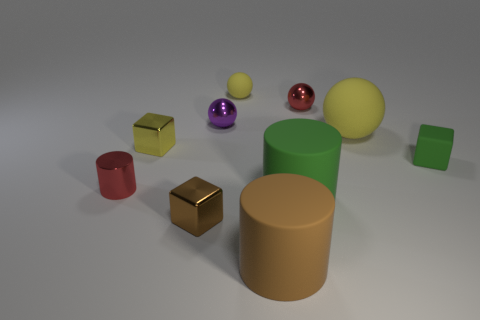Subtract 1 spheres. How many spheres are left? 3 Subtract all blocks. How many objects are left? 7 Add 1 tiny yellow things. How many tiny yellow things are left? 3 Add 6 tiny brown blocks. How many tiny brown blocks exist? 7 Subtract 1 green blocks. How many objects are left? 9 Subtract all green blocks. Subtract all yellow spheres. How many objects are left? 7 